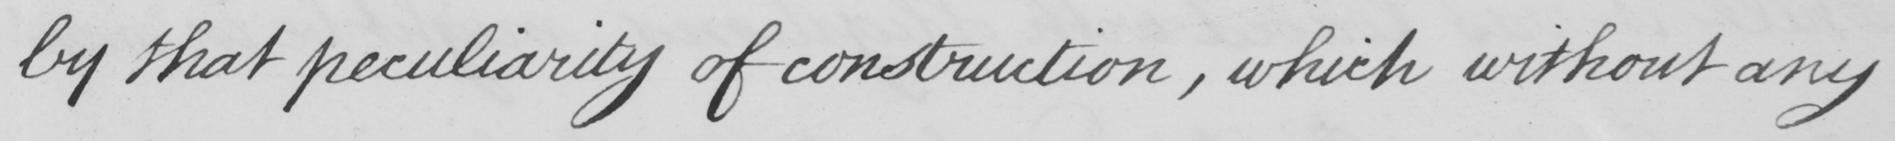Can you read and transcribe this handwriting? by that peculiarity of construction , which without any 